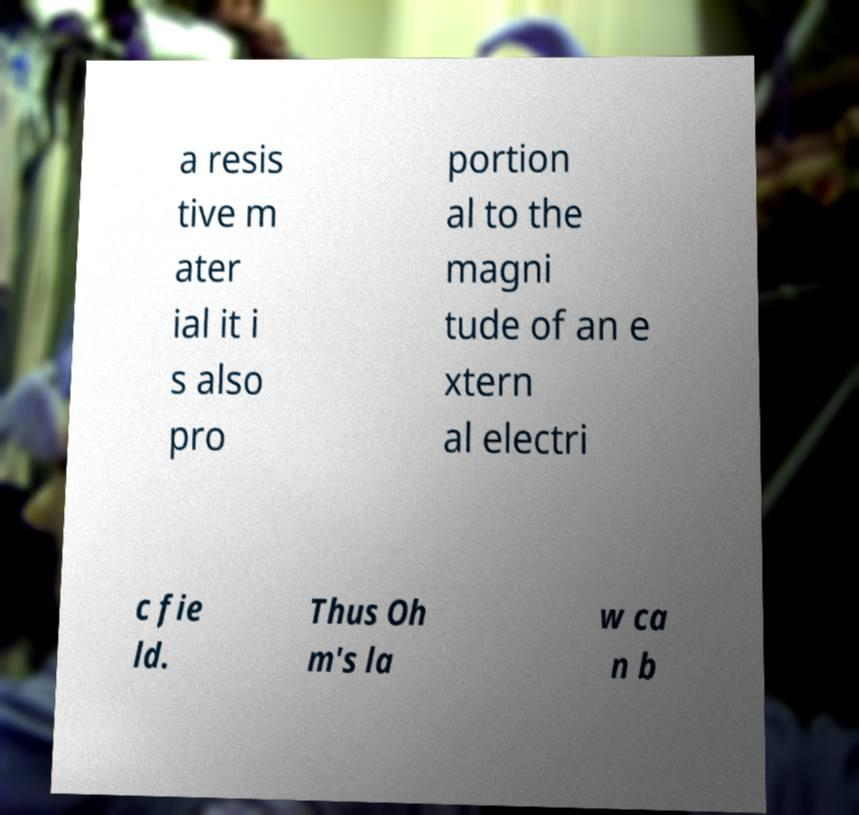There's text embedded in this image that I need extracted. Can you transcribe it verbatim? a resis tive m ater ial it i s also pro portion al to the magni tude of an e xtern al electri c fie ld. Thus Oh m's la w ca n b 